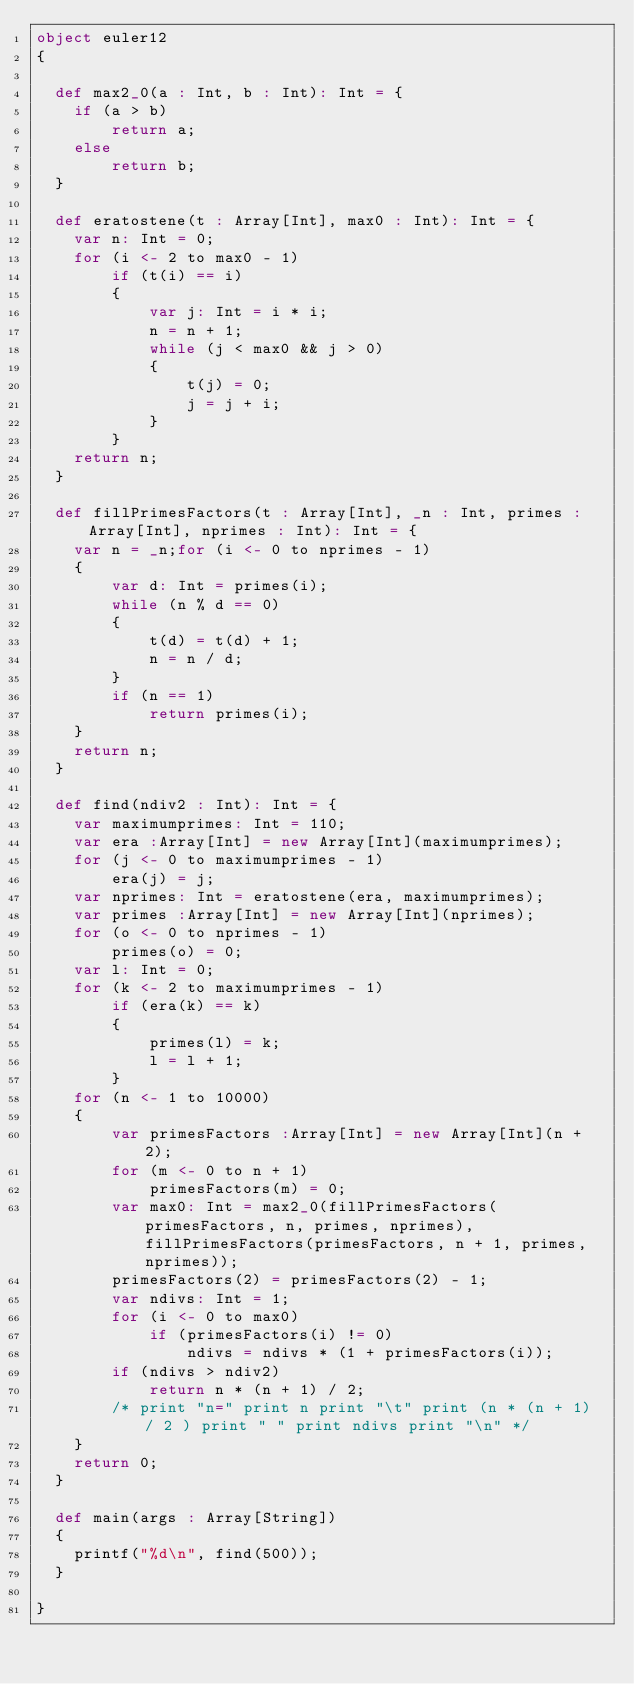Convert code to text. <code><loc_0><loc_0><loc_500><loc_500><_Scala_>object euler12
{
  
  def max2_0(a : Int, b : Int): Int = {
    if (a > b)
        return a;
    else
        return b;
  }
  
  def eratostene(t : Array[Int], max0 : Int): Int = {
    var n: Int = 0;
    for (i <- 2 to max0 - 1)
        if (t(i) == i)
        {
            var j: Int = i * i;
            n = n + 1;
            while (j < max0 && j > 0)
            {
                t(j) = 0;
                j = j + i;
            }
        }
    return n;
  }
  
  def fillPrimesFactors(t : Array[Int], _n : Int, primes : Array[Int], nprimes : Int): Int = {
    var n = _n;for (i <- 0 to nprimes - 1)
    {
        var d: Int = primes(i);
        while (n % d == 0)
        {
            t(d) = t(d) + 1;
            n = n / d;
        }
        if (n == 1)
            return primes(i);
    }
    return n;
  }
  
  def find(ndiv2 : Int): Int = {
    var maximumprimes: Int = 110;
    var era :Array[Int] = new Array[Int](maximumprimes);
    for (j <- 0 to maximumprimes - 1)
        era(j) = j;
    var nprimes: Int = eratostene(era, maximumprimes);
    var primes :Array[Int] = new Array[Int](nprimes);
    for (o <- 0 to nprimes - 1)
        primes(o) = 0;
    var l: Int = 0;
    for (k <- 2 to maximumprimes - 1)
        if (era(k) == k)
        {
            primes(l) = k;
            l = l + 1;
        }
    for (n <- 1 to 10000)
    {
        var primesFactors :Array[Int] = new Array[Int](n + 2);
        for (m <- 0 to n + 1)
            primesFactors(m) = 0;
        var max0: Int = max2_0(fillPrimesFactors(primesFactors, n, primes, nprimes), fillPrimesFactors(primesFactors, n + 1, primes, nprimes));
        primesFactors(2) = primesFactors(2) - 1;
        var ndivs: Int = 1;
        for (i <- 0 to max0)
            if (primesFactors(i) != 0)
                ndivs = ndivs * (1 + primesFactors(i));
        if (ndivs > ndiv2)
            return n * (n + 1) / 2;
        /* print "n=" print n print "\t" print (n * (n + 1) / 2 ) print " " print ndivs print "\n" */
    }
    return 0;
  }
  
  def main(args : Array[String])
  {
    printf("%d\n", find(500));
  }
  
}

</code> 